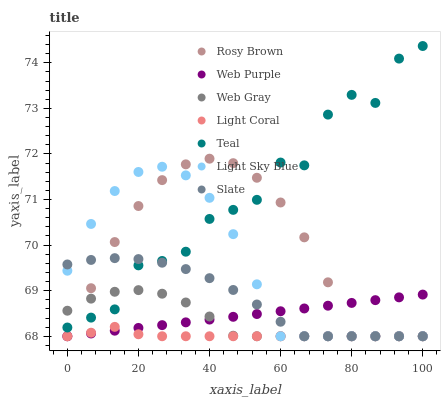Does Light Coral have the minimum area under the curve?
Answer yes or no. Yes. Does Teal have the maximum area under the curve?
Answer yes or no. Yes. Does Slate have the minimum area under the curve?
Answer yes or no. No. Does Slate have the maximum area under the curve?
Answer yes or no. No. Is Web Purple the smoothest?
Answer yes or no. Yes. Is Teal the roughest?
Answer yes or no. Yes. Is Slate the smoothest?
Answer yes or no. No. Is Slate the roughest?
Answer yes or no. No. Does Web Gray have the lowest value?
Answer yes or no. Yes. Does Teal have the lowest value?
Answer yes or no. No. Does Teal have the highest value?
Answer yes or no. Yes. Does Slate have the highest value?
Answer yes or no. No. Is Light Coral less than Teal?
Answer yes or no. Yes. Is Teal greater than Web Purple?
Answer yes or no. Yes. Does Light Coral intersect Slate?
Answer yes or no. Yes. Is Light Coral less than Slate?
Answer yes or no. No. Is Light Coral greater than Slate?
Answer yes or no. No. Does Light Coral intersect Teal?
Answer yes or no. No. 